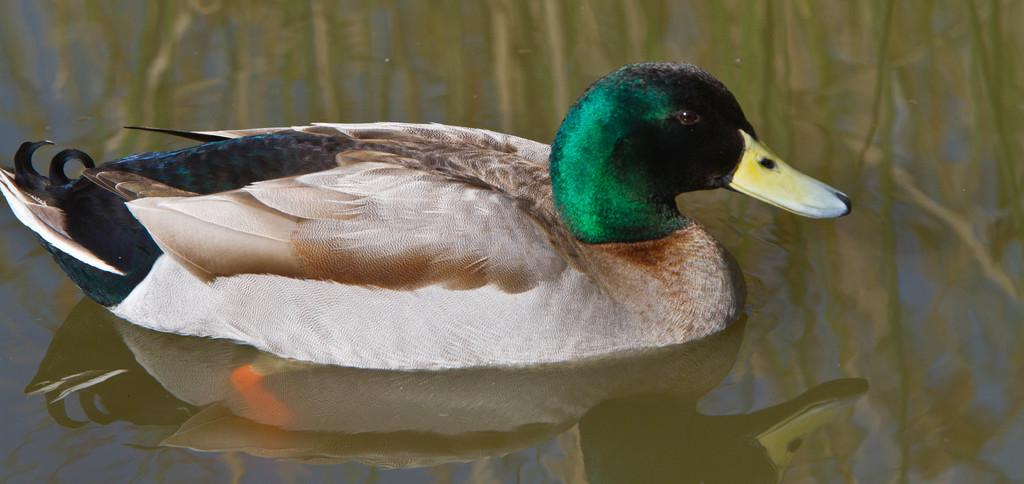What type of animal is in the image? There is a duck in the image. What colors can be seen on the duck? The duck has white, brown, black, and green colors. Where is the duck located in the image? The duck is in the water. What type of food is the duck holding in its beak in the image? There is no food visible in the image; the duck is simply in the water. 